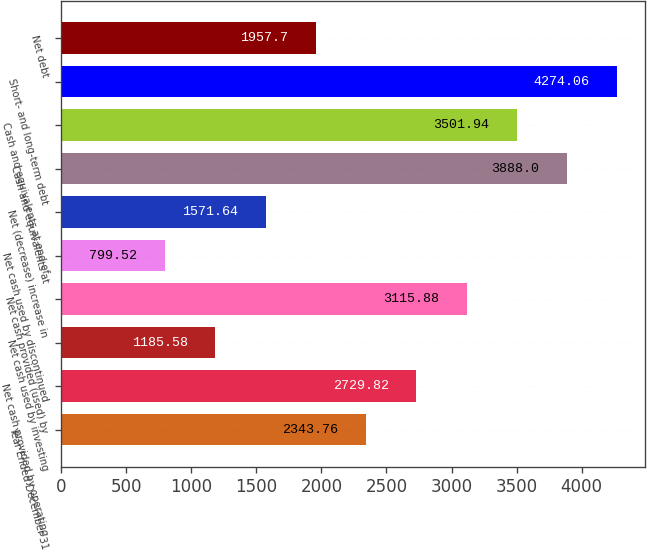Convert chart to OTSL. <chart><loc_0><loc_0><loc_500><loc_500><bar_chart><fcel>Year Ended December 31<fcel>Net cash provided by operating<fcel>Net cash used by investing<fcel>Net cash provided (used) by<fcel>Net cash used by discontinued<fcel>Net (decrease) increase in<fcel>Cash and equivalents at<fcel>Cash and equivalents at end of<fcel>Short- and long-term debt<fcel>Net debt<nl><fcel>2343.76<fcel>2729.82<fcel>1185.58<fcel>3115.88<fcel>799.52<fcel>1571.64<fcel>3888<fcel>3501.94<fcel>4274.06<fcel>1957.7<nl></chart> 